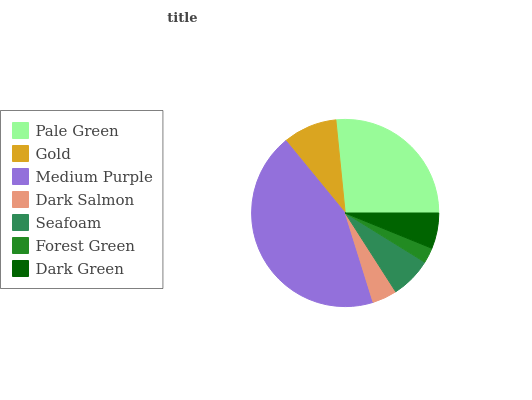Is Forest Green the minimum?
Answer yes or no. Yes. Is Medium Purple the maximum?
Answer yes or no. Yes. Is Gold the minimum?
Answer yes or no. No. Is Gold the maximum?
Answer yes or no. No. Is Pale Green greater than Gold?
Answer yes or no. Yes. Is Gold less than Pale Green?
Answer yes or no. Yes. Is Gold greater than Pale Green?
Answer yes or no. No. Is Pale Green less than Gold?
Answer yes or no. No. Is Seafoam the high median?
Answer yes or no. Yes. Is Seafoam the low median?
Answer yes or no. Yes. Is Medium Purple the high median?
Answer yes or no. No. Is Forest Green the low median?
Answer yes or no. No. 